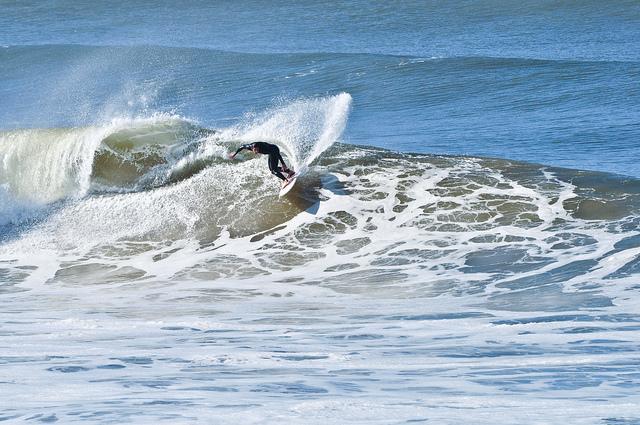How many arms is this man holding in the air?
Concise answer only. 1. What is this man doing?
Short answer required. Surfing. Are there waves in the water?
Concise answer only. Yes. 